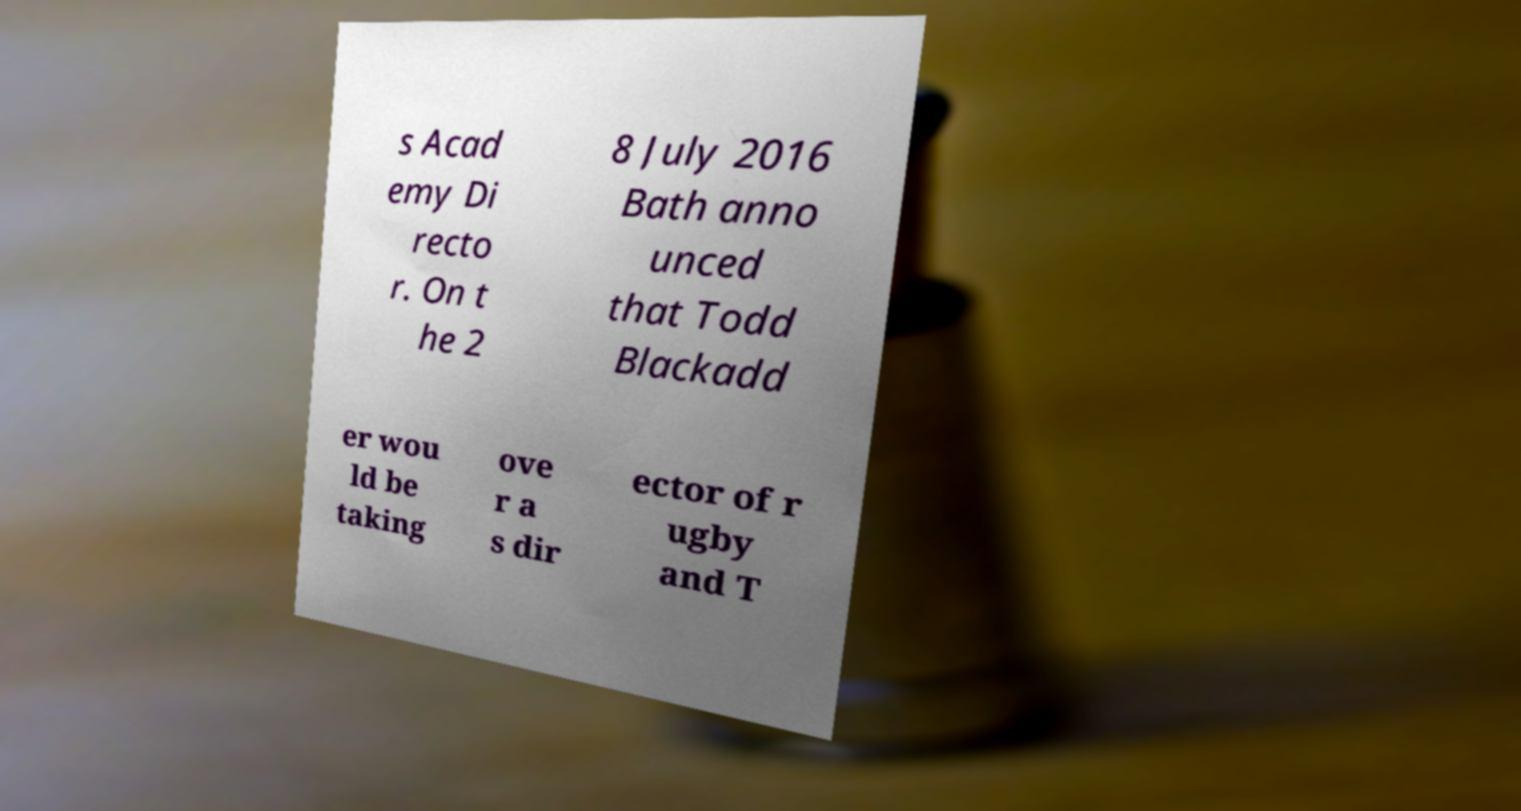Could you assist in decoding the text presented in this image and type it out clearly? s Acad emy Di recto r. On t he 2 8 July 2016 Bath anno unced that Todd Blackadd er wou ld be taking ove r a s dir ector of r ugby and T 